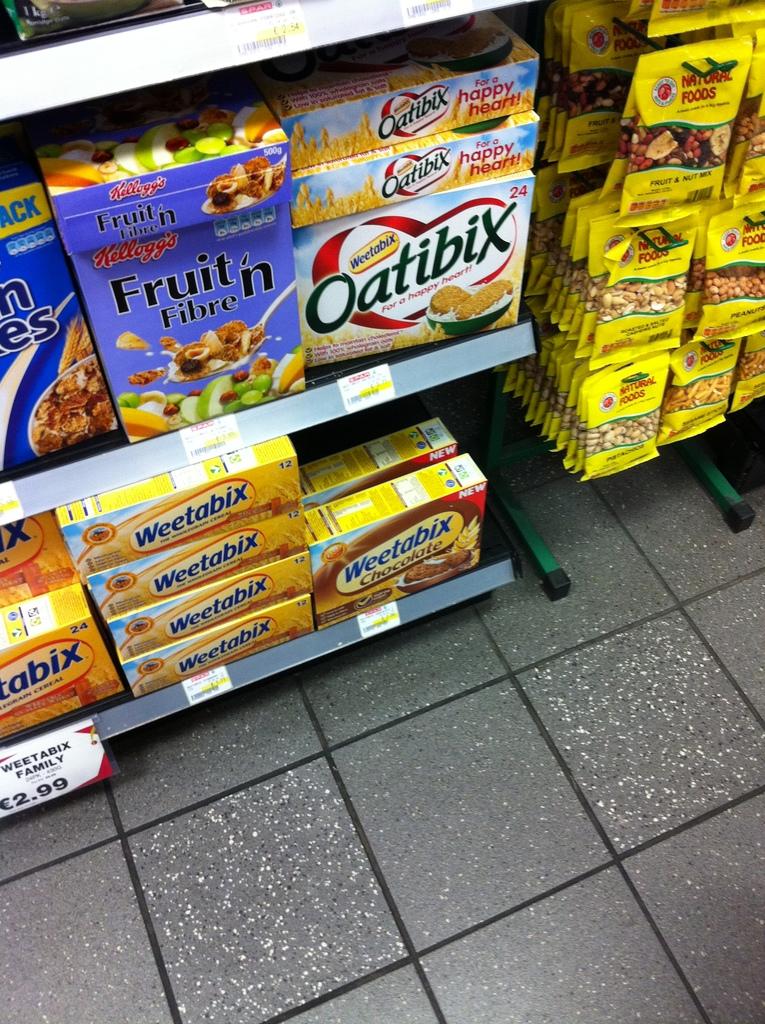How much do the weetabix cost?
Provide a succinct answer. 2.99. 